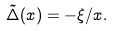<formula> <loc_0><loc_0><loc_500><loc_500>\tilde { \Delta } ( x ) = - \xi / x .</formula> 